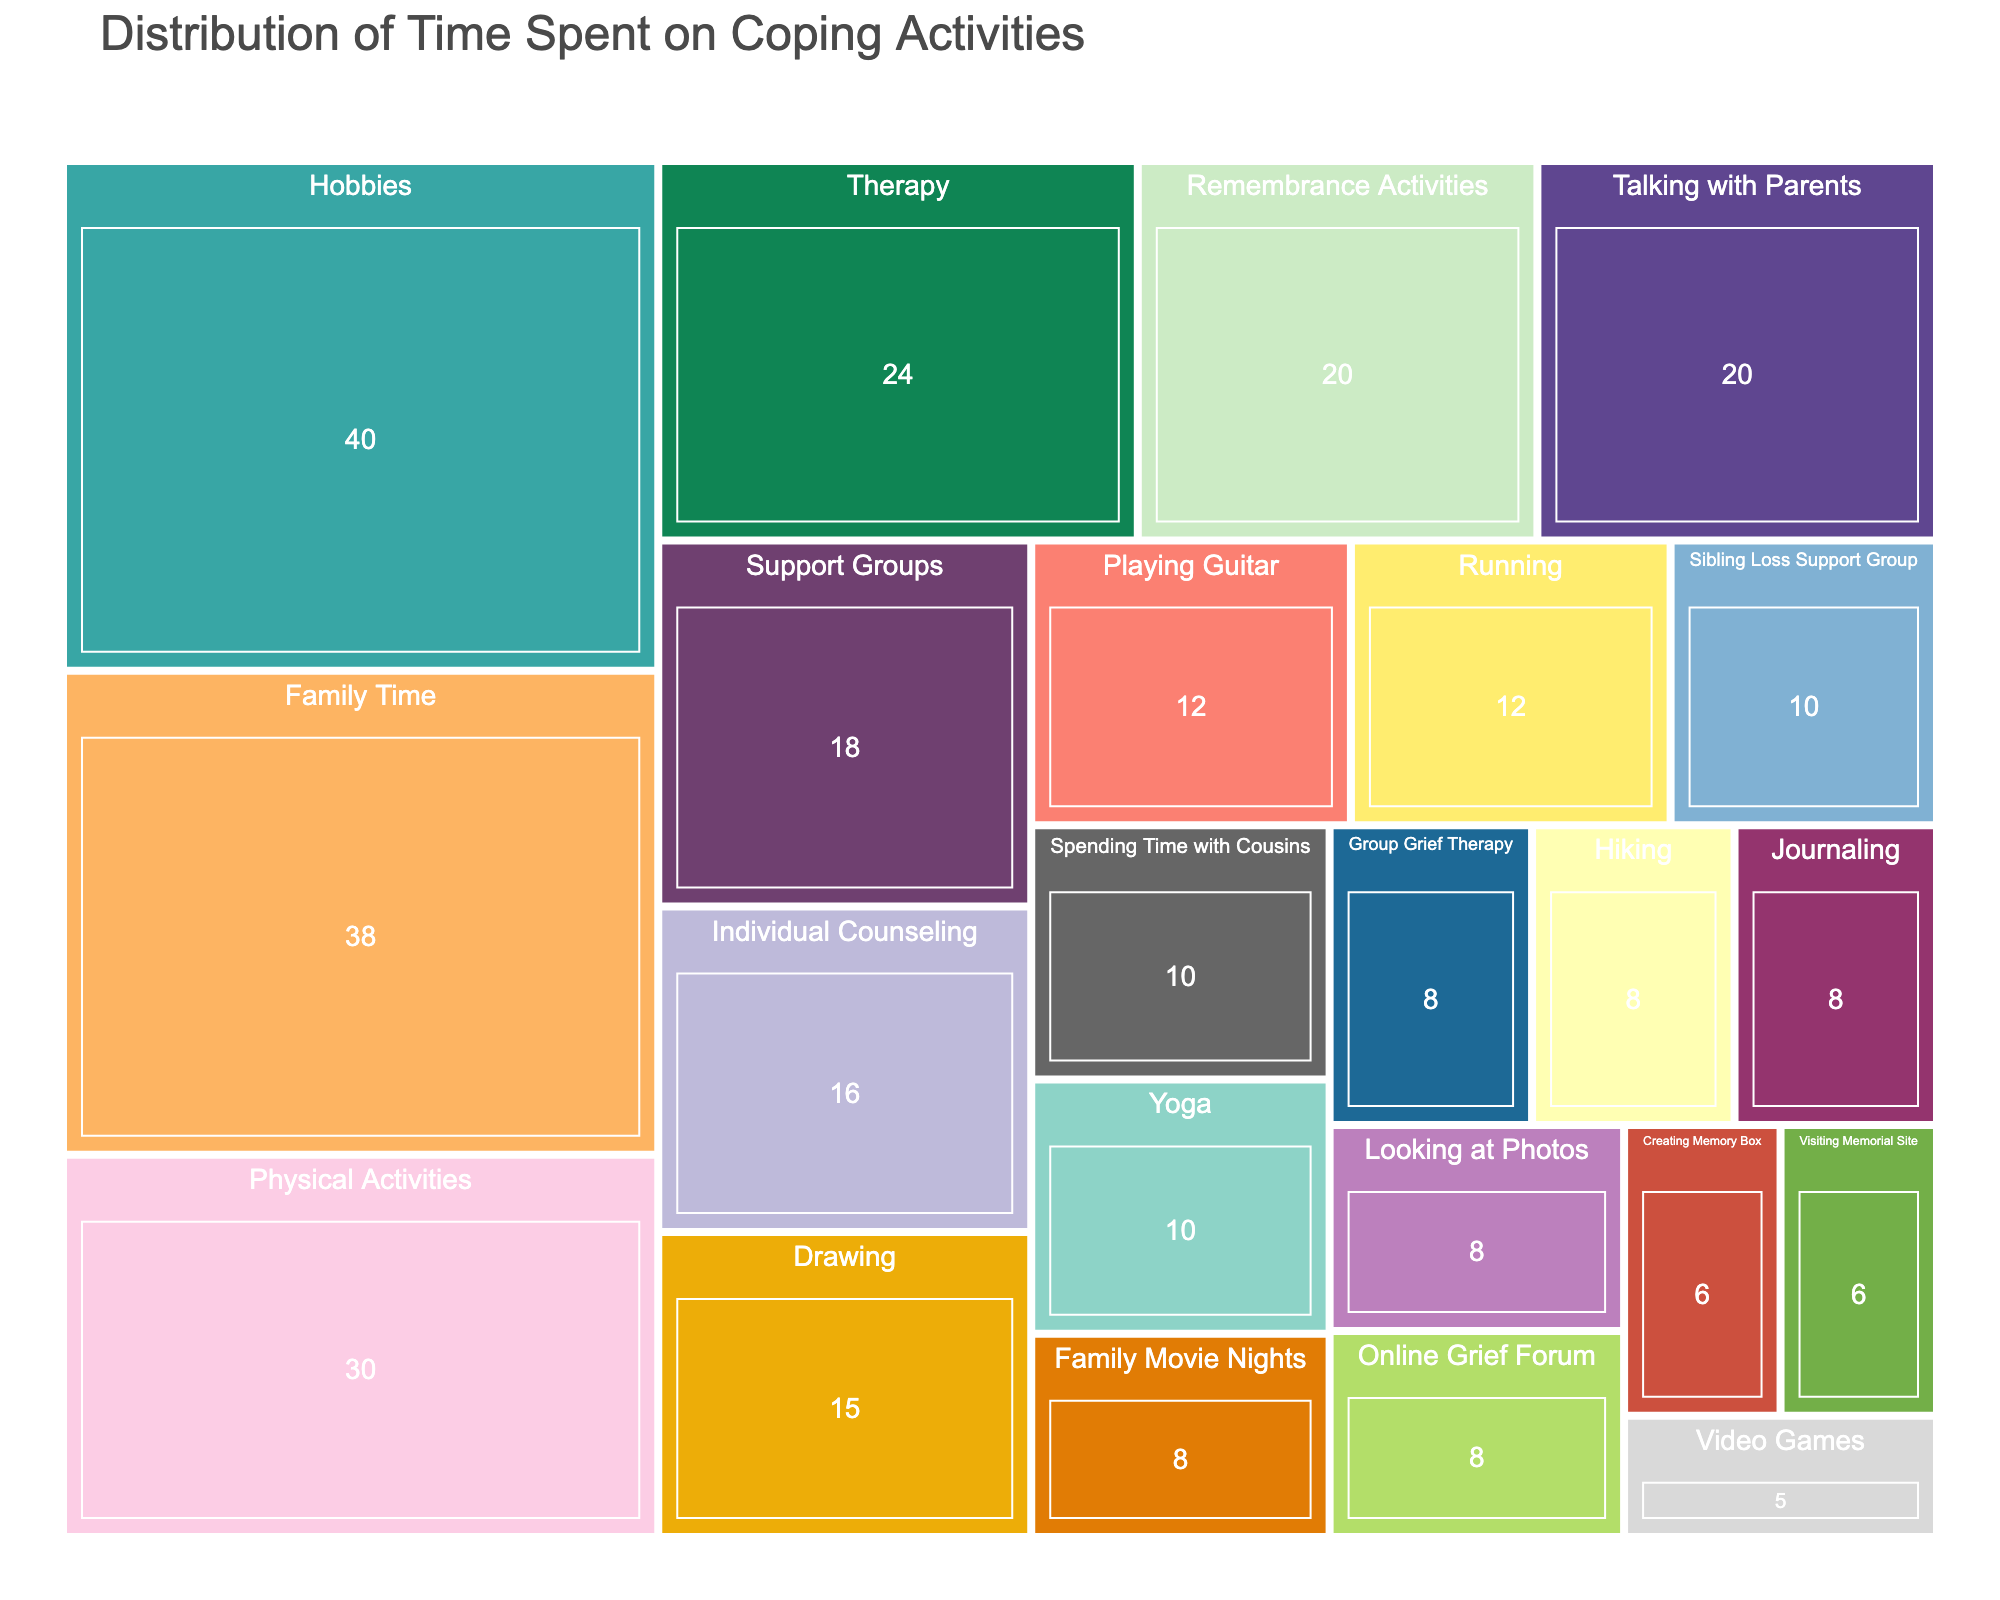What's the title of the figure? The title is typically found at the top of the figure. In this case, it's indicated in the code with title='Distribution of Time Spent on Coping Activities'.
Answer: Distribution of Time Spent on Coping Activities How many hours were spent on hobbies? Locate the "Hobbies" section in the treemap, and sum the hours listed under it (Drawing, Playing Guitar, Journaling, Video Games). Drawing: 15, Playing Guitar: 12, Journaling: 8, Video Games: 5; Total = 15 + 12 + 8 + 5 = 40 hours.
Answer: 40 hours Which activity under the "Physical Activities" category took the most time? Review the sub-sections under "Physical Activities" in the treemap. Running: 12, Yoga: 10, Hiking: 8. Running has the highest value of 12 hours.
Answer: Running Are more hours spent on "Family Time" or "Hobbies"? Compare the total hours listed under "Family Time" (38 hours) and "Hobbies" (40 hours). "Hobbies" have more hours (40) compared to "Family Time" (38).
Answer: Hobbies What's the total time spent on "Support Groups"? Sum the hours listed under "Support Groups" (Sibling Loss Support Group, Online Grief Forum). Sibling Loss Support Group: 10, Online Grief Forum: 8; Total = 10 + 8 = 18 hours.
Answer: 18 hours What is the least time-consuming activity under "Remembrance Activities"? Review the sub-sections under "Remembrance Activities". Looking at Photos: 8, Visiting Memorial Site: 6, Creating Memory Box: 6. Both Visiting Memorial Site and Creating Memory Box have the smallest value of 6 hours.
Answer: Visiting Memorial Site and Creating Memory Box Which main category had the highest number of sub-activities? Count the sub-activities under each main category. Therapy: 2, Hobbies: 4, Support Groups: 2, Physical Activities: 3, Remembrance Activities: 3, Family Time: 3. Hobbies has the most sub-activities with 4.
Answer: Hobbies What's the total time spent on "Yoga" and "Drawing" combined? Add the time spent on Yoga (10 hours) and Drawing (15 hours). 10 + 15 = 25 hours.
Answer: 25 hours How many hours were spent on "Therapy" related activities overall? Sum the hours listed under "Therapy" (Individual Counseling, Group Grief Therapy). Individual Counseling: 16, Group Grief Therapy: 8; Total = 16 + 8 = 24 hours.
Answer: 24 hours 